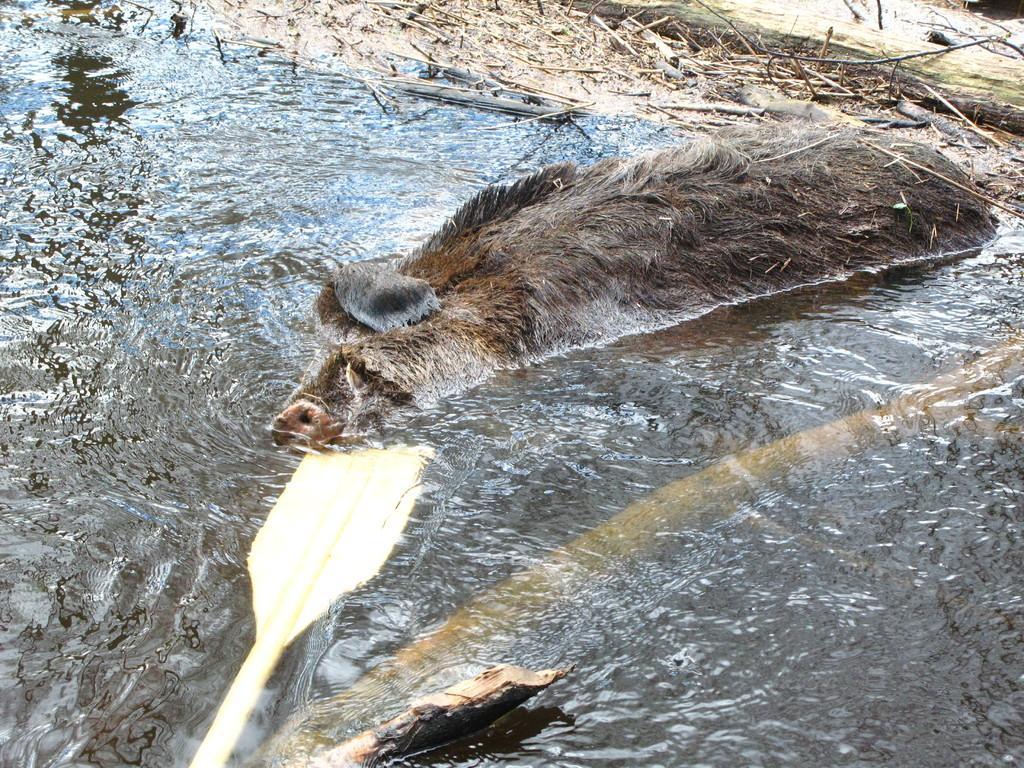How would you summarize this image in a sentence or two? In this image we can see an animal swimming in the water and twigs. 